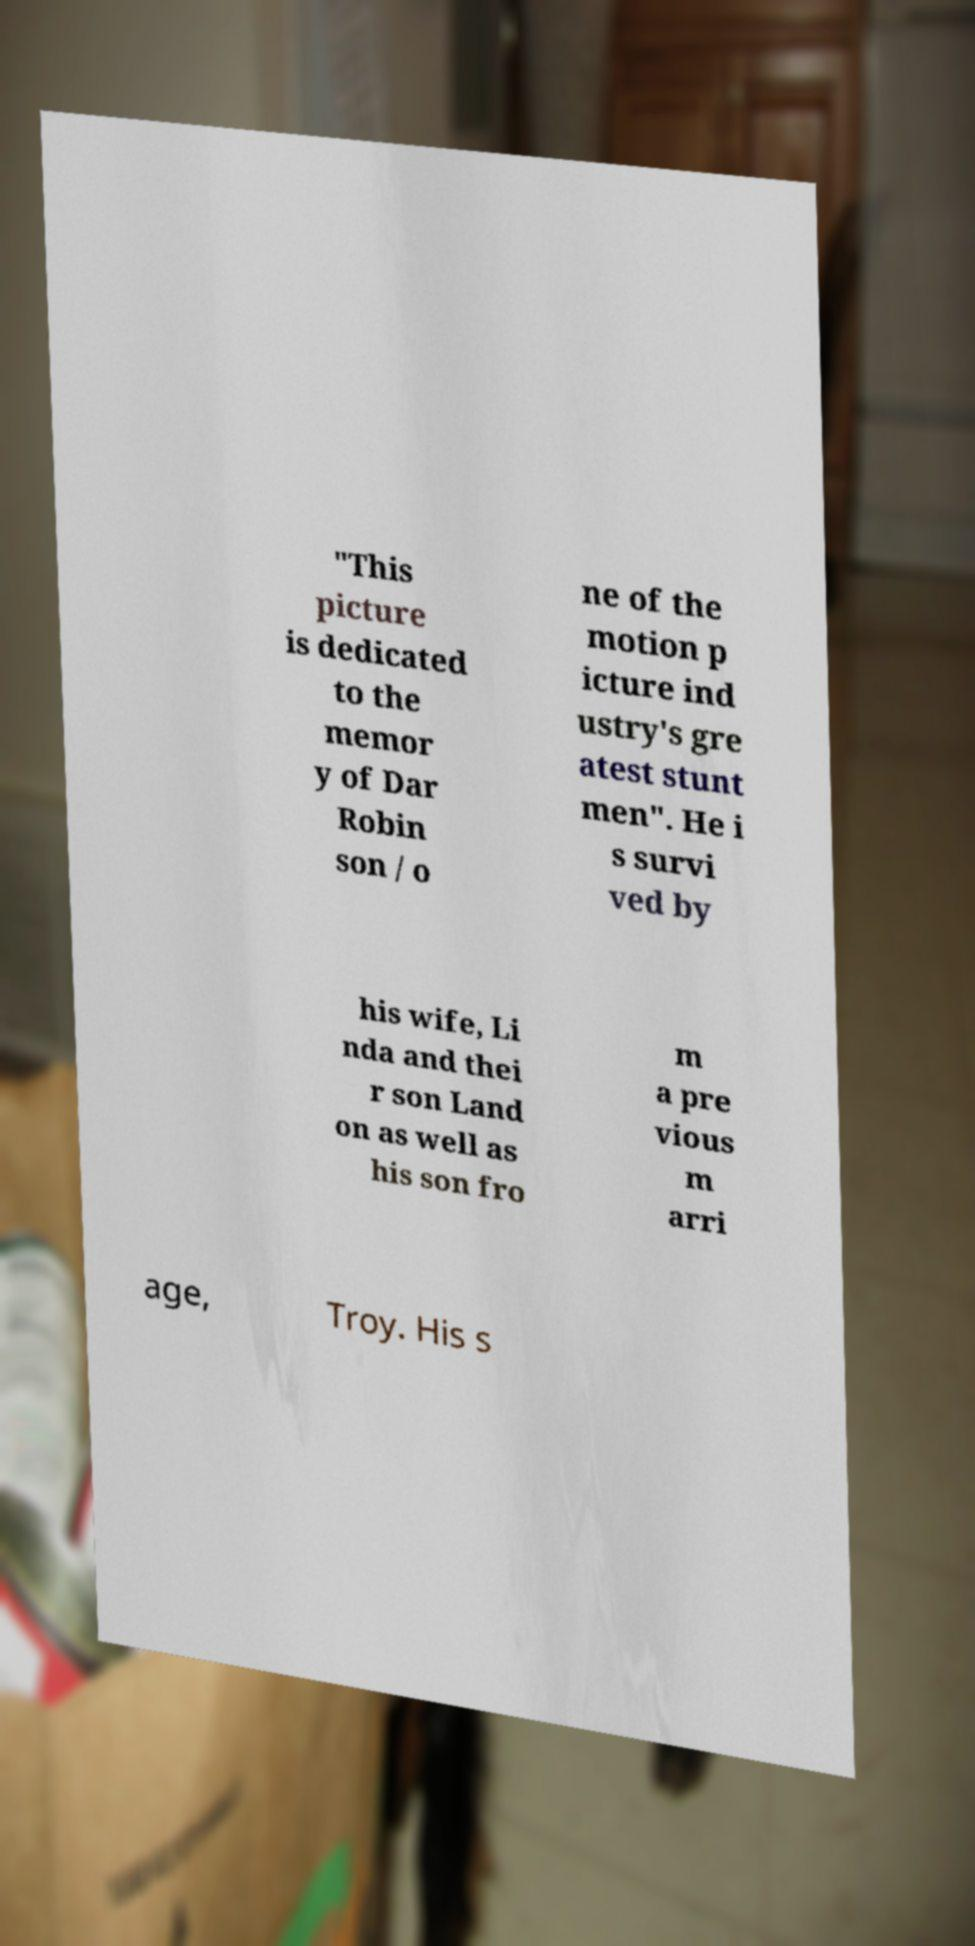Could you assist in decoding the text presented in this image and type it out clearly? "This picture is dedicated to the memor y of Dar Robin son / o ne of the motion p icture ind ustry's gre atest stunt men". He i s survi ved by his wife, Li nda and thei r son Land on as well as his son fro m a pre vious m arri age, Troy. His s 